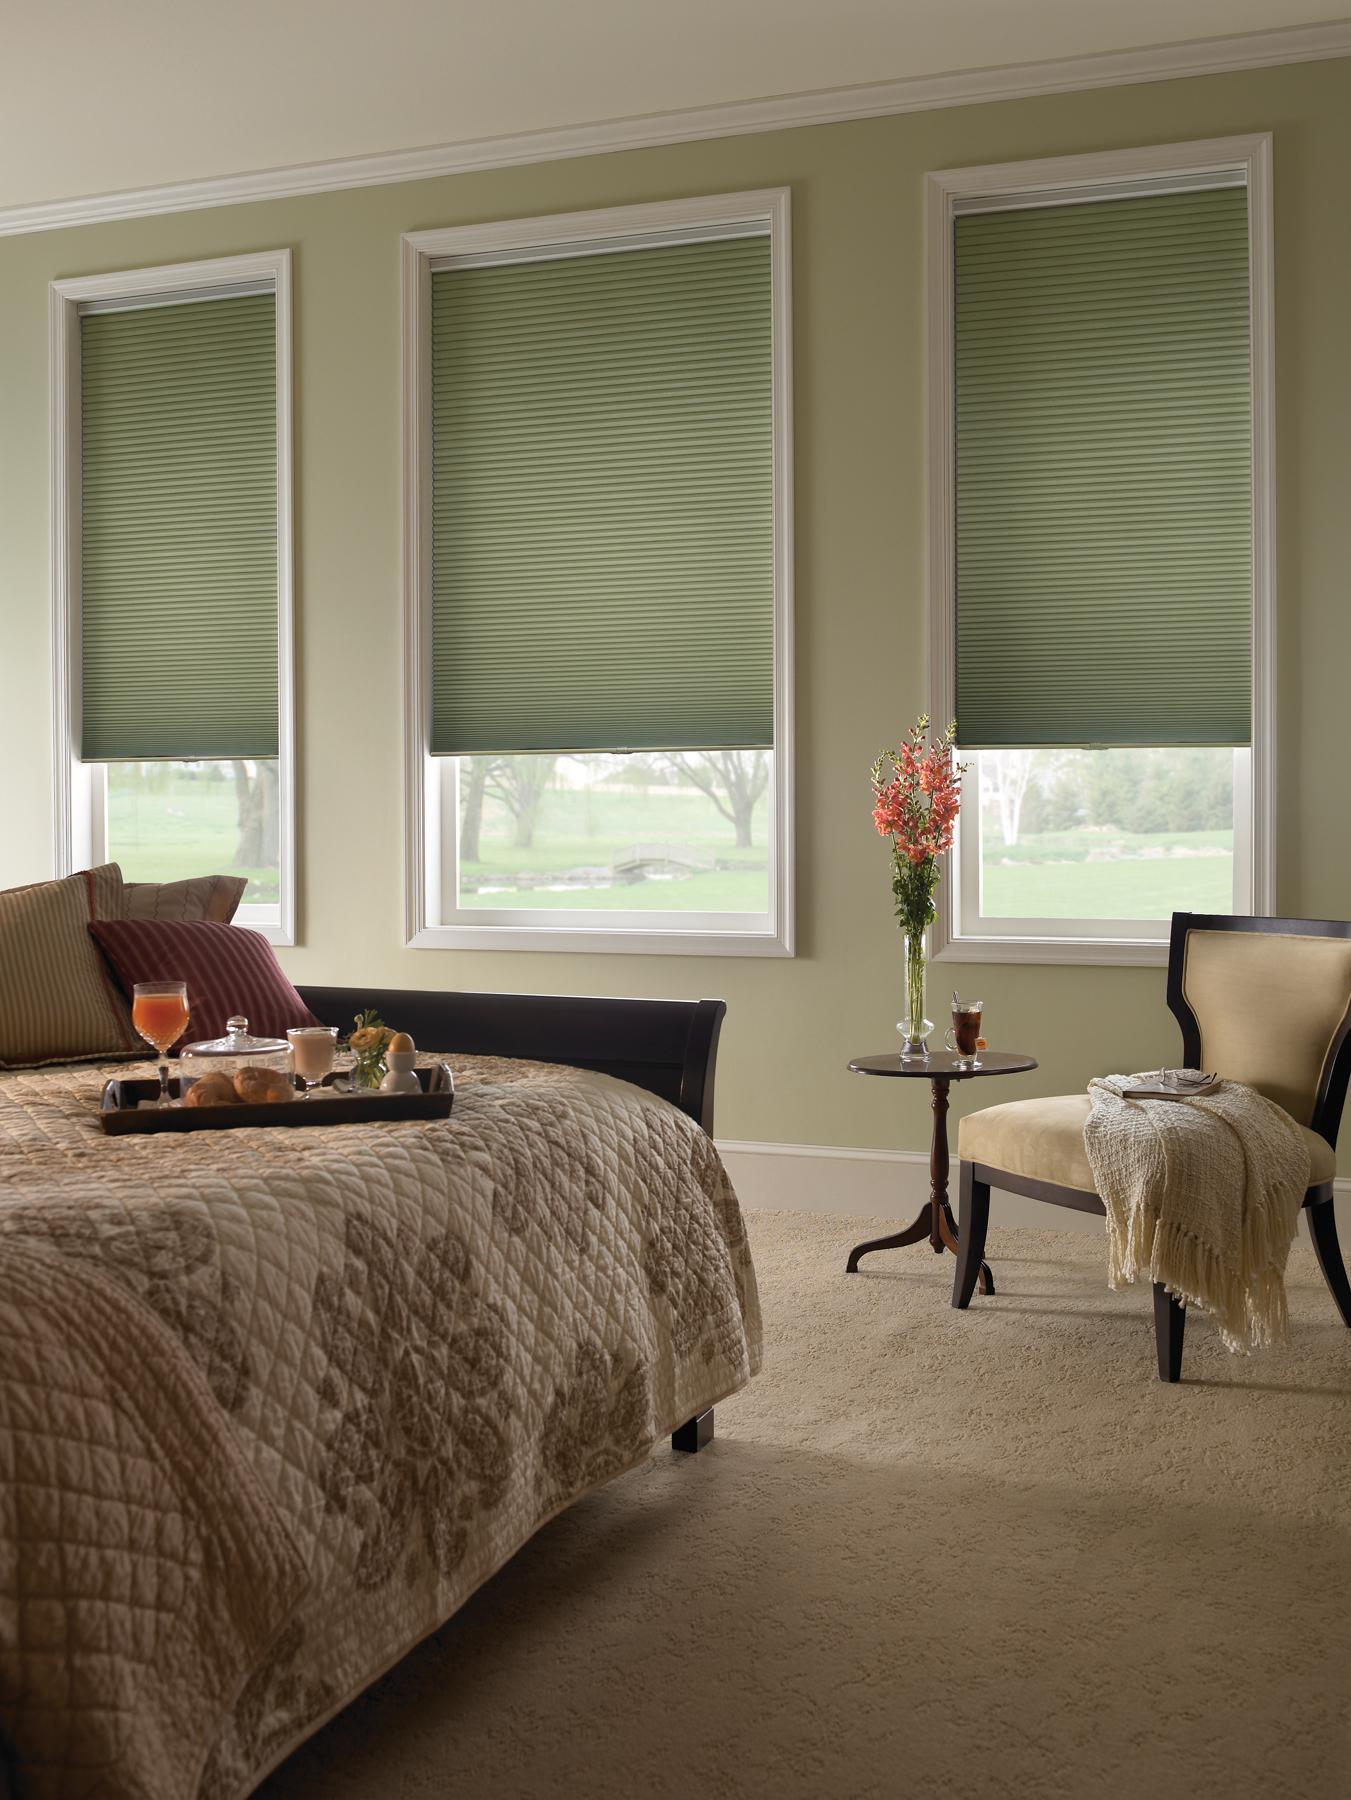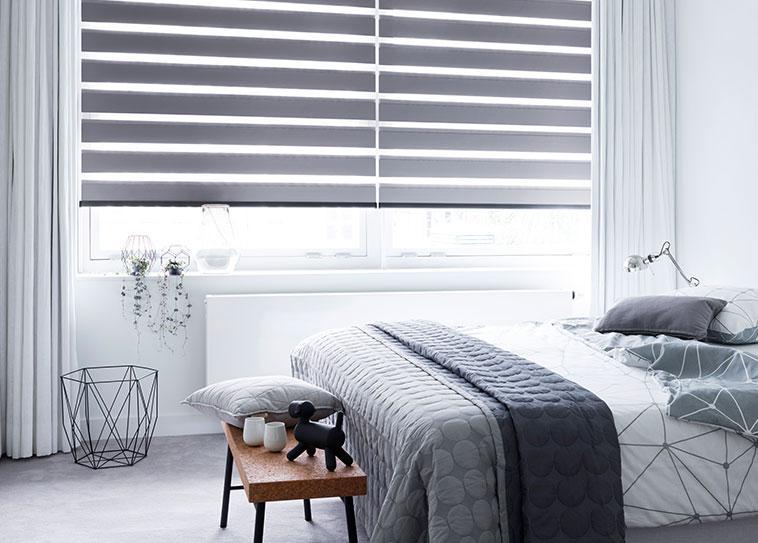The first image is the image on the left, the second image is the image on the right. Assess this claim about the two images: "One image shows the headboard of a bed in front of two windows with solid-colored shades, and a table lamp is nearby on a dresser.". Correct or not? Answer yes or no. No. The first image is the image on the left, the second image is the image on the right. Examine the images to the left and right. Is the description "There is a total of four blinds." accurate? Answer yes or no. Yes. 